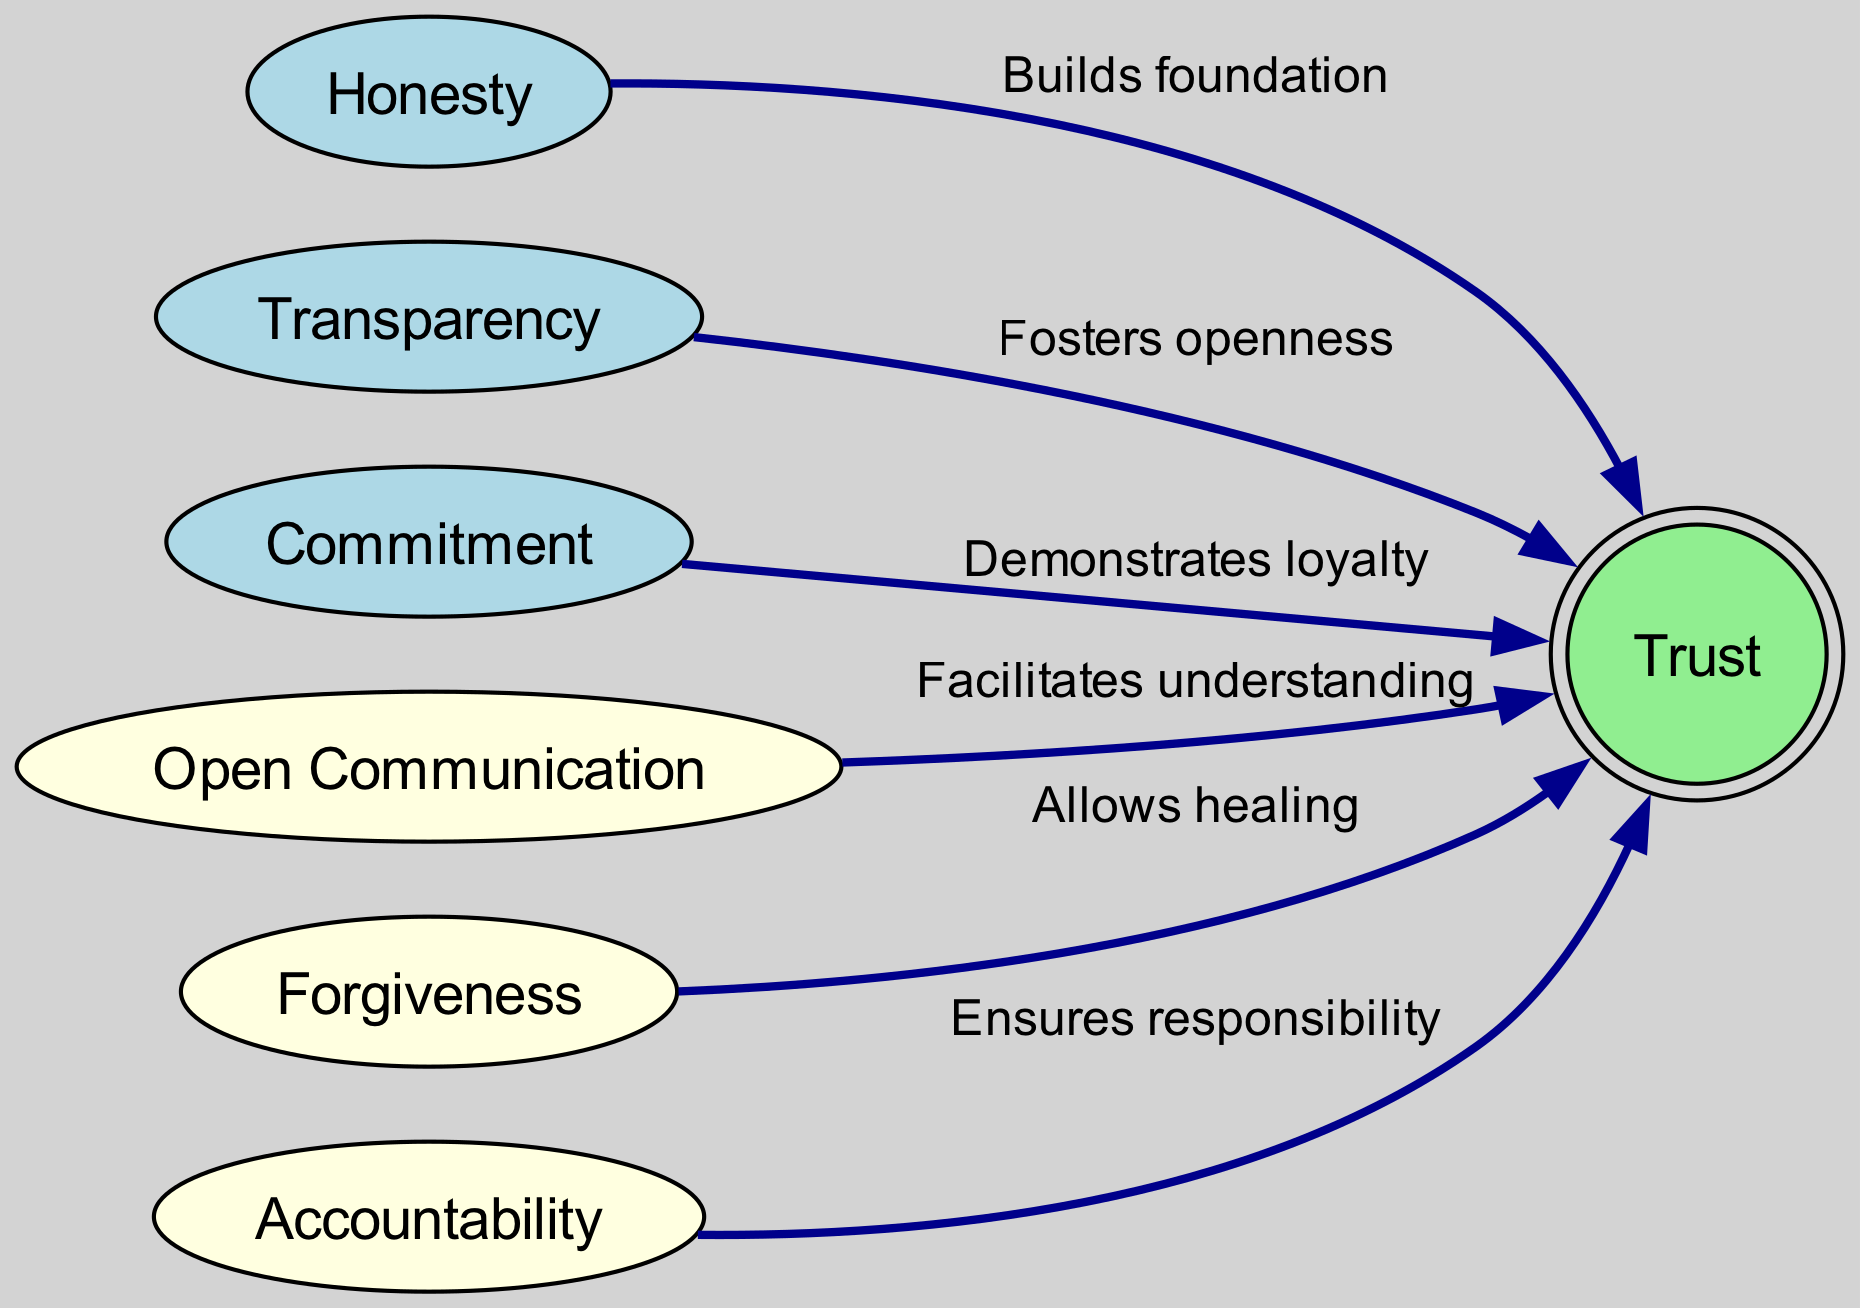What is the output node in the diagram? The only output node is labeled "Trust," which represents the final outcome of the different input factors.
Answer: Trust How many input nodes are present in the diagram? There are three input nodes: "Honesty," "Transparency," and "Commitment." Counting these nodes gives a total of three input nodes in the diagram.
Answer: 3 Which factor builds a foundation for trust? The diagram indicates that "Honesty" is the factor that builds the foundation for trust. This is connected by an edge labeled "Builds foundation."
Answer: Honesty What do transparency and trust have in common? Both are connected by an edge labeled "Fosters openness," indicating the relationship where transparency enhances or encourages trust.
Answer: Fosters openness What is the relationship between commitment and trust? The edge between "Commitment" and "Trust" describes this relationship with the label "Demonstrates loyalty," showing that commitment influences trust through loyalty.
Answer: Demonstrates loyalty Which hidden factor facilitates understanding in the relationship? The factor that facilitates understanding, which is crucial for rebuilding trust, is "Open Communication," as shown by its connection to the output node.
Answer: Open Communication How many edges are in the diagram? Counting the edges connected to the nodes, there are six edges that represent the relationships between input, hidden, and output nodes.
Answer: 6 What does the factor "Forgiveness" contribute to trust? The edge from "Forgiveness" to "Trust" is labeled "Allows healing," indicating that forgiveness plays a role in the healing process, which can help rebuild trust.
Answer: Allows healing Which hidden factor ensures responsibility in the relationship? The factor "Accountability" is primarily responsible for ensuring that individuals take ownership of their actions, thus contributing to trust.
Answer: Accountability 